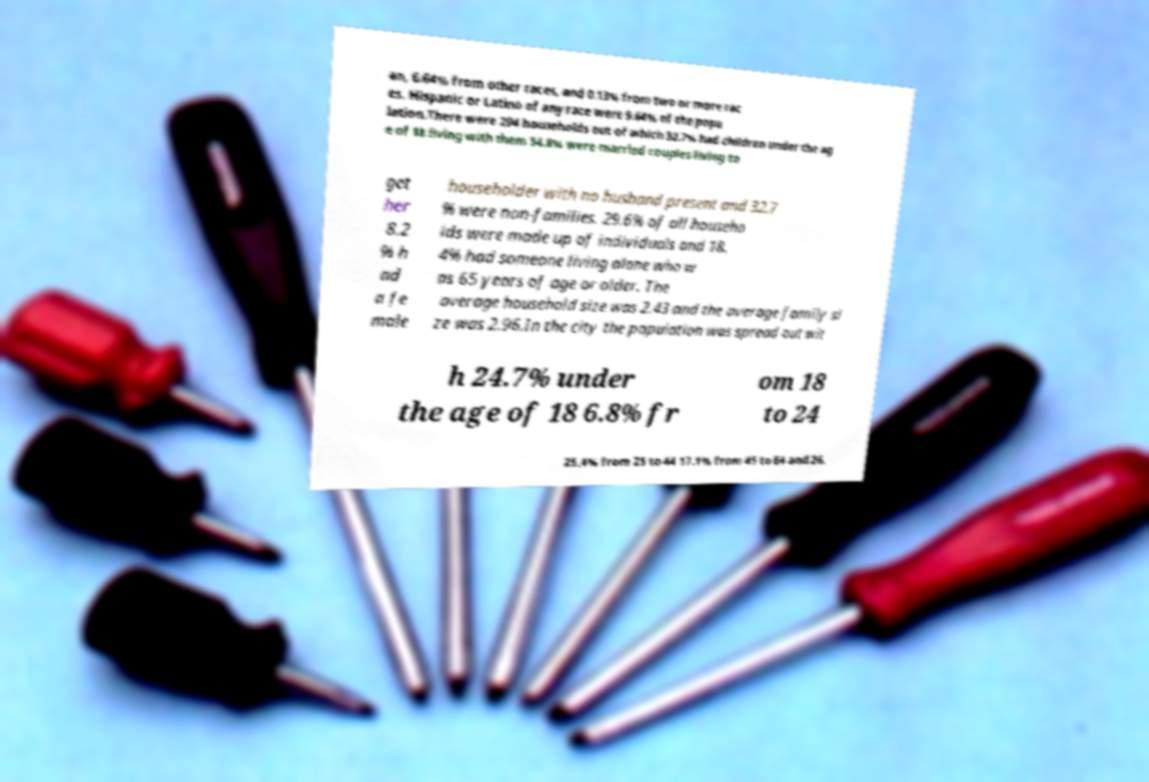Could you extract and type out the text from this image? an, 6.64% from other races, and 0.13% from two or more rac es. Hispanic or Latino of any race were 9.64% of the popu lation.There were 294 households out of which 32.7% had children under the ag e of 18 living with them 54.8% were married couples living to get her 8.2 % h ad a fe male householder with no husband present and 32.7 % were non-families. 29.6% of all househo lds were made up of individuals and 18. 4% had someone living alone who w as 65 years of age or older. The average household size was 2.43 and the average family si ze was 2.96.In the city the population was spread out wit h 24.7% under the age of 18 6.8% fr om 18 to 24 25.4% from 25 to 44 17.1% from 45 to 64 and 26. 